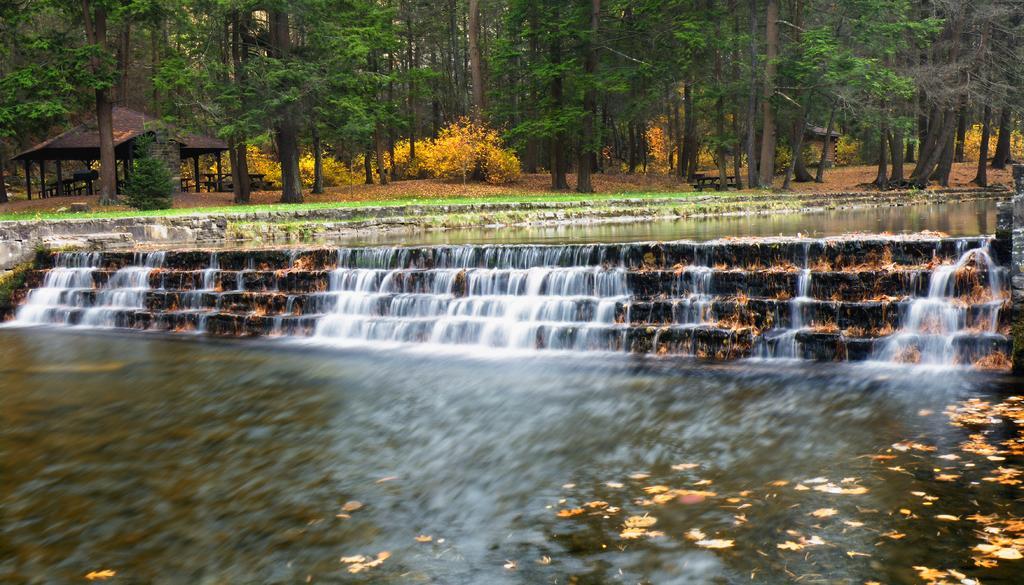Please provide a concise description of this image. In the middle of this image I can see the stairs and also I can see the water. In the background there are many trees and plants. On the left side there is a shed. 